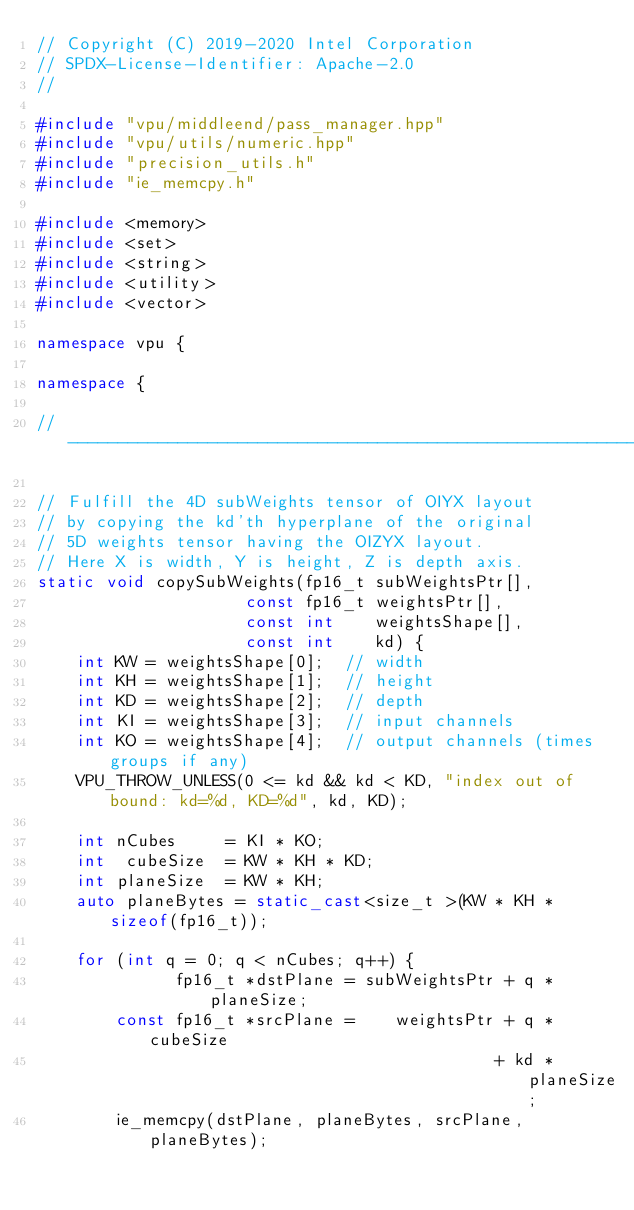<code> <loc_0><loc_0><loc_500><loc_500><_C++_>// Copyright (C) 2019-2020 Intel Corporation
// SPDX-License-Identifier: Apache-2.0
//

#include "vpu/middleend/pass_manager.hpp"
#include "vpu/utils/numeric.hpp"
#include "precision_utils.h"
#include "ie_memcpy.h"

#include <memory>
#include <set>
#include <string>
#include <utility>
#include <vector>

namespace vpu {

namespace {

//----------------------------------------------------------------------

// Fulfill the 4D subWeights tensor of OIYX layout
// by copying the kd'th hyperplane of the original
// 5D weights tensor having the OIZYX layout.
// Here X is width, Y is height, Z is depth axis.
static void copySubWeights(fp16_t subWeightsPtr[],
                     const fp16_t weightsPtr[],
                     const int    weightsShape[],
                     const int    kd) {
    int KW = weightsShape[0];  // width
    int KH = weightsShape[1];  // height
    int KD = weightsShape[2];  // depth
    int KI = weightsShape[3];  // input channels
    int KO = weightsShape[4];  // output channels (times groups if any)
    VPU_THROW_UNLESS(0 <= kd && kd < KD, "index out of bound: kd=%d, KD=%d", kd, KD);

    int nCubes     = KI * KO;
    int  cubeSize  = KW * KH * KD;
    int planeSize  = KW * KH;
    auto planeBytes = static_cast<size_t >(KW * KH * sizeof(fp16_t));

    for (int q = 0; q < nCubes; q++) {
              fp16_t *dstPlane = subWeightsPtr + q * planeSize;
        const fp16_t *srcPlane =    weightsPtr + q *  cubeSize
                                              + kd * planeSize;
        ie_memcpy(dstPlane, planeBytes, srcPlane, planeBytes);</code> 